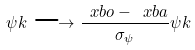<formula> <loc_0><loc_0><loc_500><loc_500>\psi k \longrightarrow \frac { \ x b o - \ x b a } { \sigma _ { \psi } } \psi k</formula> 